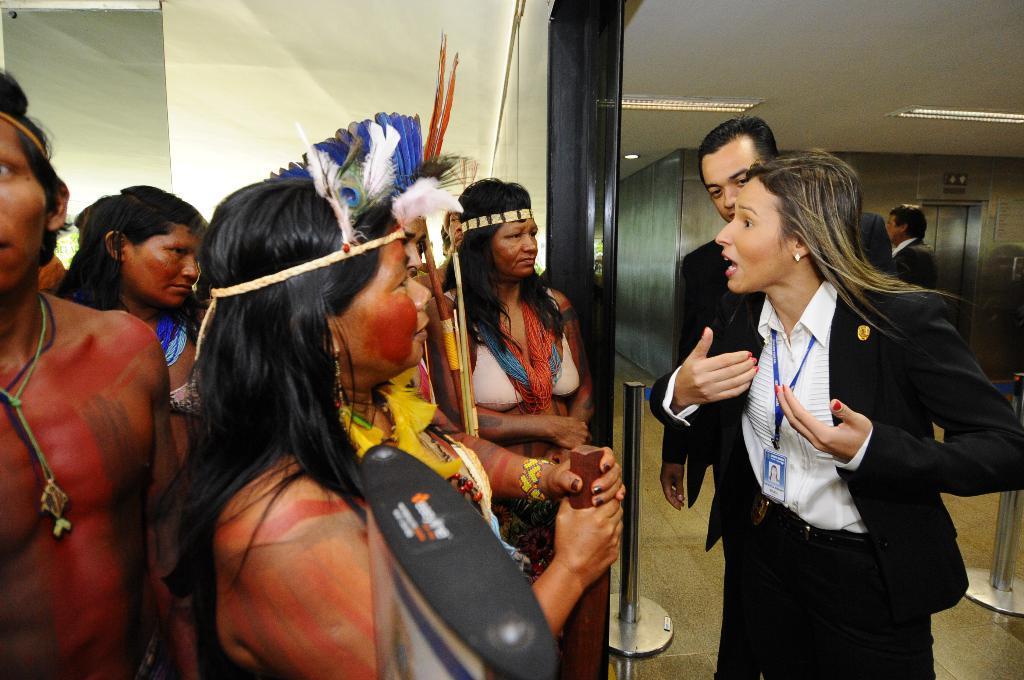Please provide a concise description of this image. In this image there are people standing. The people to the left seems to be tribal people. To the right there is a woman and a man standing. Behind them there is a wall. Beside them there is a rod. The woman to the right is wearing an identity card. There are lights to the ceiling. 